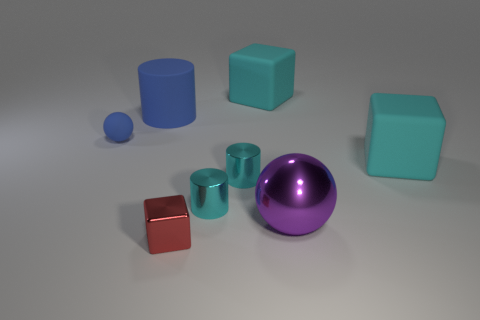What shape is the big thing that is on the left side of the purple object and to the right of the shiny cube?
Make the answer very short. Cube. What is the size of the cyan block that is behind the tiny thing that is left of the red metal cube?
Make the answer very short. Large. What number of other objects are the same color as the large shiny thing?
Your response must be concise. 0. What is the material of the purple thing?
Provide a succinct answer. Metal. Is there a gray object?
Your response must be concise. No. Is the number of small things that are to the left of the rubber cylinder the same as the number of large purple things?
Your answer should be compact. Yes. Are there any other things that are the same material as the large purple sphere?
Your answer should be very brief. Yes. How many tiny objects are red blocks or red metallic cylinders?
Ensure brevity in your answer.  1. There is a rubber object that is the same color as the large cylinder; what is its shape?
Offer a terse response. Sphere. Is the sphere on the right side of the small red metal thing made of the same material as the red block?
Provide a short and direct response. Yes. 